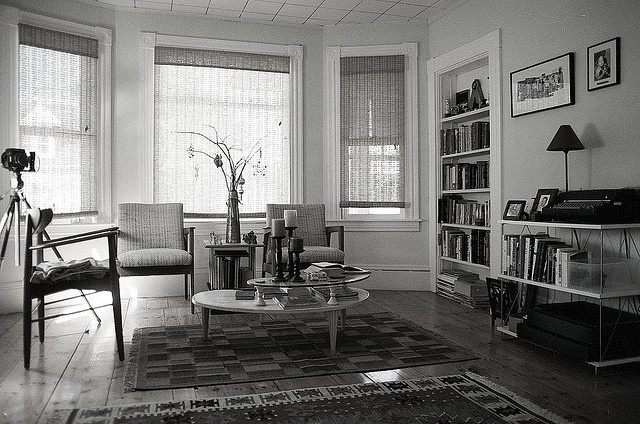Describe the objects in this image and their specific colors. I can see book in black, gray, darkgray, and lightgray tones, chair in black, lightgray, gray, and darkgray tones, chair in black, darkgray, gray, and lightgray tones, chair in black and gray tones, and book in black, gray, darkgray, and lightgray tones in this image. 